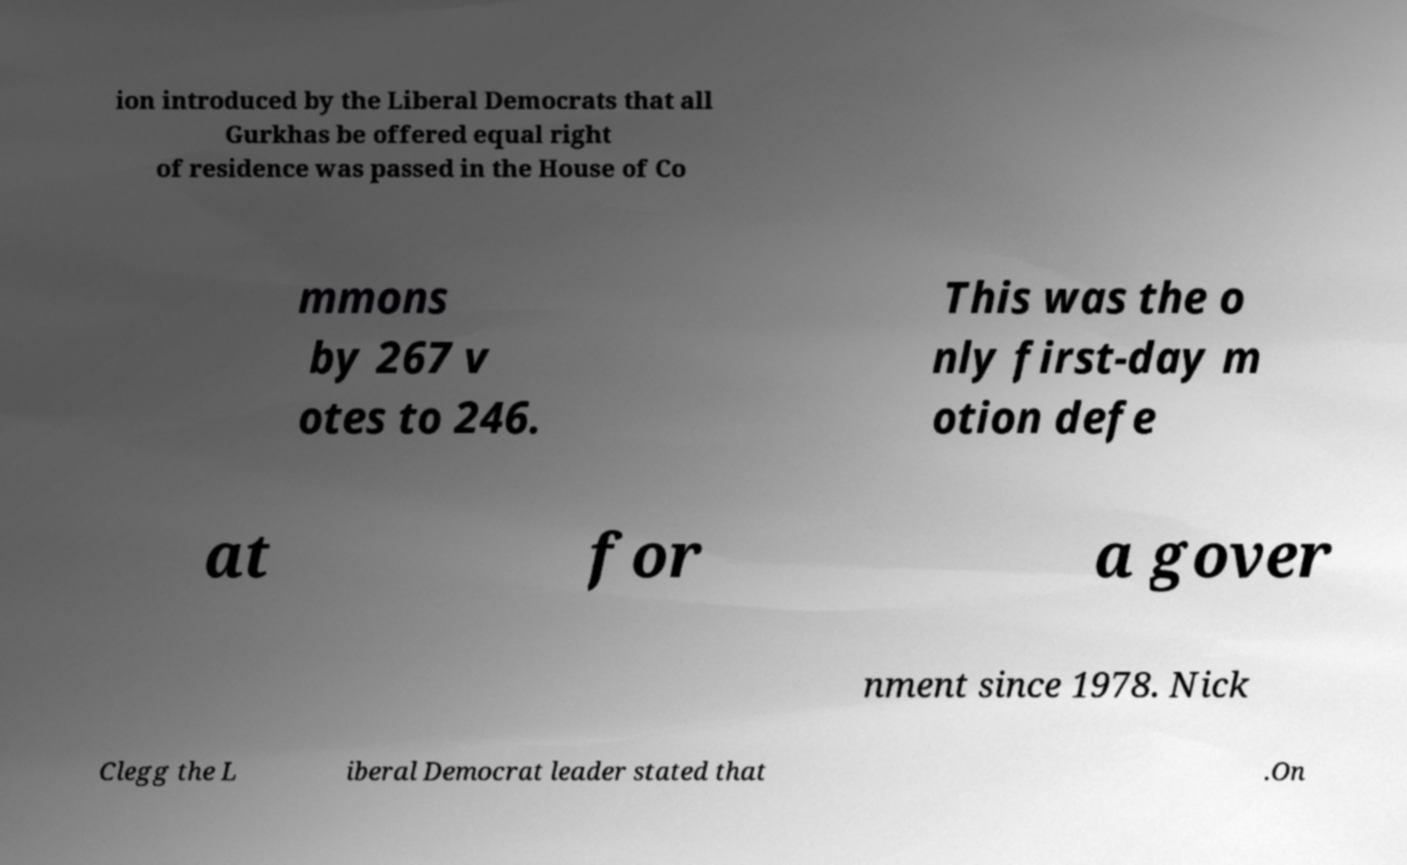For documentation purposes, I need the text within this image transcribed. Could you provide that? ion introduced by the Liberal Democrats that all Gurkhas be offered equal right of residence was passed in the House of Co mmons by 267 v otes to 246. This was the o nly first-day m otion defe at for a gover nment since 1978. Nick Clegg the L iberal Democrat leader stated that .On 